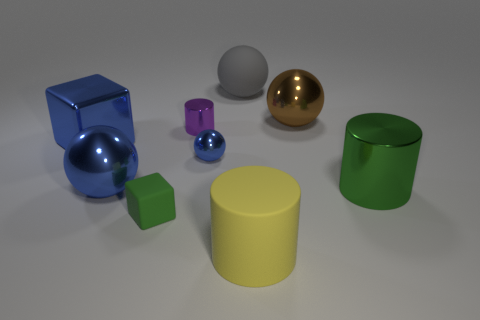Considering the lighting in the image, where do you think the source of light is located? The shadows are oriented mostly to the left, suggesting the light source is coming from the top-right angle outside the field of view. 